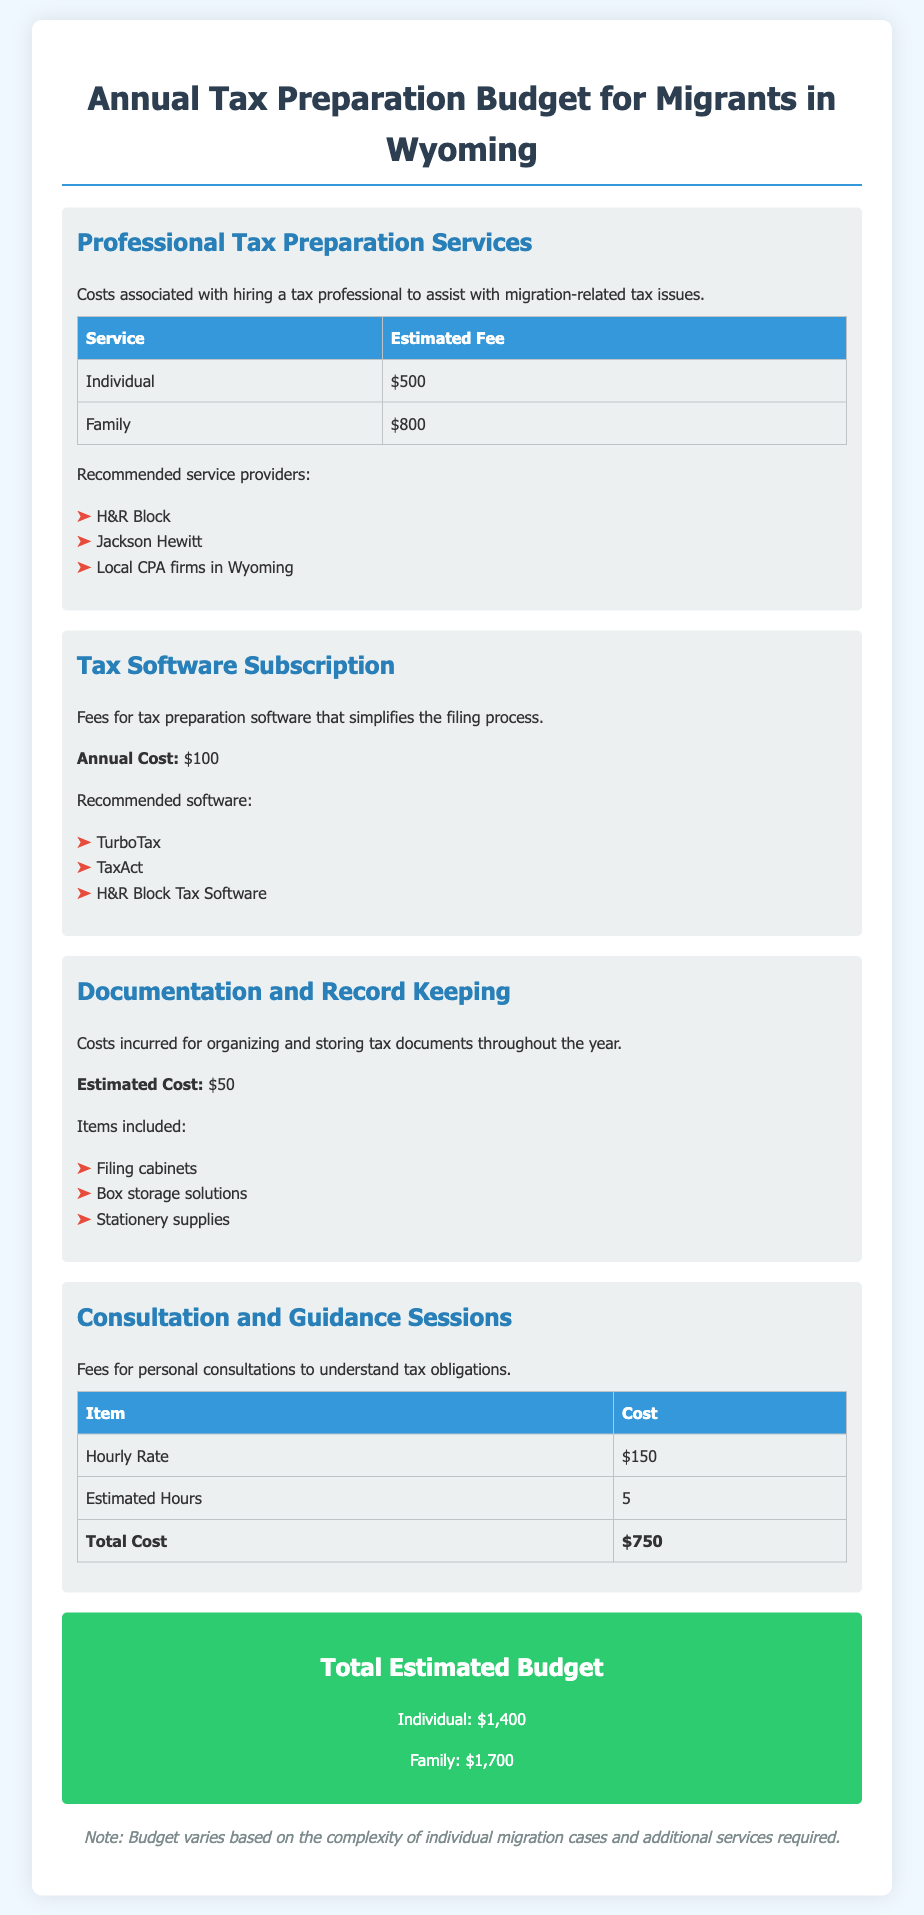what is the estimated fee for an individual tax preparation service? The estimated fee for an individual tax preparation service is specified in the table, which shows $500.
Answer: $500 what is the total estimated budget for a family? The total estimated budget for a family is outlined in the total budget section, which mentions $1,700.
Answer: $1,700 how much does the tax software subscription cost annually? The annual cost for tax software subscription is stated as $100 in the document.
Answer: $100 what is the hourly rate for consultation sessions? The document lists the hourly rate for consultation sessions as $150.
Answer: $150 which company is suggested for tax software? The document recommends several companies, including TurboTax, which is one of the listed options.
Answer: TurboTax what is included in the documentation and record keeping costs? The document identifies filing cabinets, box storage solutions, and stationery supplies as items included in the costs.
Answer: Filing cabinets, box storage solutions, stationery supplies how many estimated hours are suggested for consultation? The document specifies that the estimated hours for consultation sessions are 5.
Answer: 5 what is the total cost for consultation sessions? The total cost for consultation sessions is calculated by multiplying the hourly rate and estimated hours, resulting in $750 as mentioned in the table.
Answer: $750 who are the recommended service providers for tax preparation? The document includes H&R Block, Jackson Hewitt, and Local CPA firms in Wyoming as recommended service providers.
Answer: H&R Block, Jackson Hewitt, Local CPA firms in Wyoming 